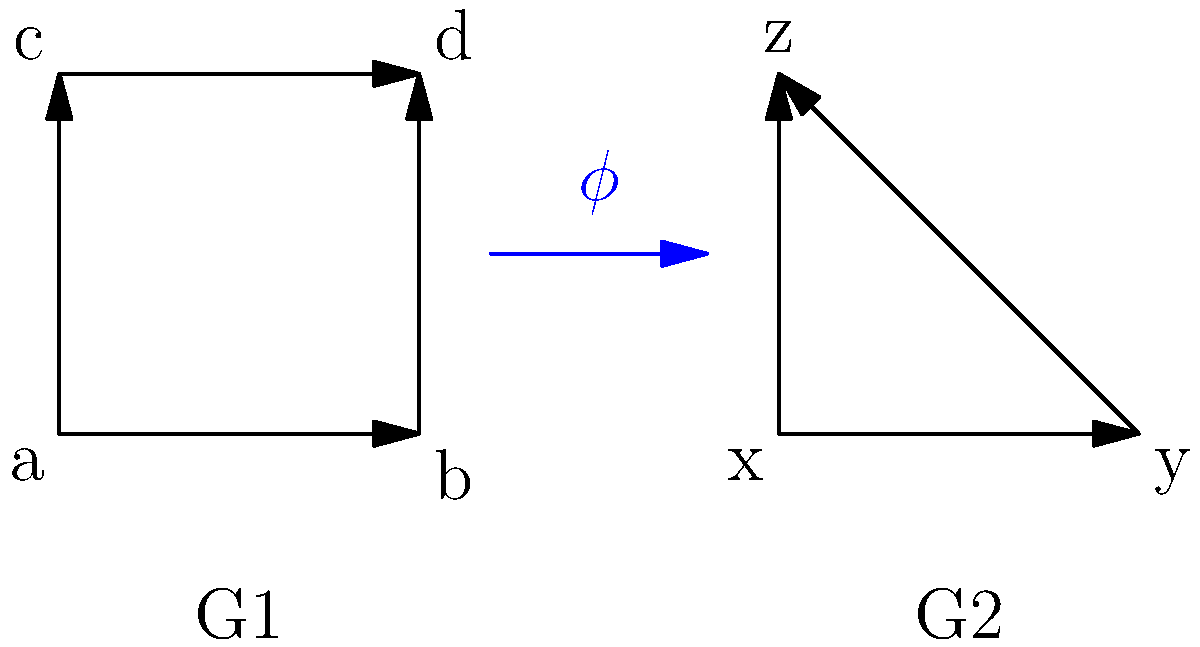Consider the directed graphs representing two groups G1 and G2. A homomorphism $\phi: G1 \rightarrow G2$ is defined. Given that $\phi(a) = x$ and $\phi(b) = y$, determine $\phi(d)$ and explain why this must be the case, considering the properties of group homomorphisms and the structure of the graphs. To solve this problem, we need to follow these steps:

1) Recall the definition of a group homomorphism: For all elements $g, h \in G1$, $\phi(gh) = \phi(g)\phi(h)$.

2) Observe the structure of G1:
   - $d = b * c$ (following the arrows)
   - $c = a * c$ (following the arrows)

3) Apply the homomorphism property:
   $\phi(d) = \phi(b * c) = \phi(b) * \phi(c)$

4) We know $\phi(a) = x$ and $\phi(b) = y$. We need to find $\phi(c)$.

5) Using the fact that $c = a * c$ in G1:
   $\phi(c) = \phi(a * c) = \phi(a) * \phi(c) = x * \phi(c)$

6) In G2, the only element that satisfies $x * z = z$ is $z$.
   Therefore, $\phi(c) = z$.

7) Now we can determine $\phi(d)$:
   $\phi(d) = \phi(b) * \phi(c) = y * z$

8) In G2, $y * z = z$

Therefore, $\phi(d) = z$.

This solution maintains the structure of the groups and satisfies the properties of a group homomorphism.
Answer: $\phi(d) = z$ 